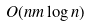<formula> <loc_0><loc_0><loc_500><loc_500>O ( n m \log n )</formula> 